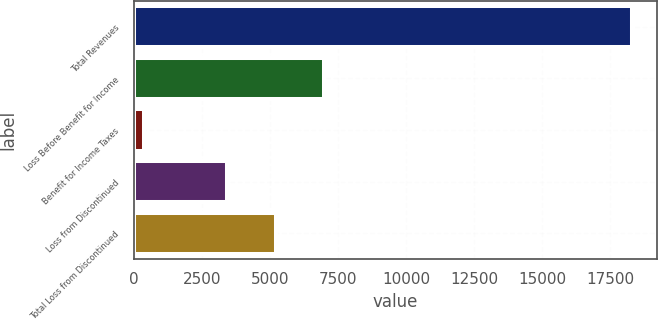Convert chart. <chart><loc_0><loc_0><loc_500><loc_500><bar_chart><fcel>Total Revenues<fcel>Loss Before Benefit for Income<fcel>Benefit for Income Taxes<fcel>Loss from Discontinued<fcel>Total Loss from Discontinued<nl><fcel>18284<fcel>6991.6<fcel>351<fcel>3405<fcel>5198.3<nl></chart> 